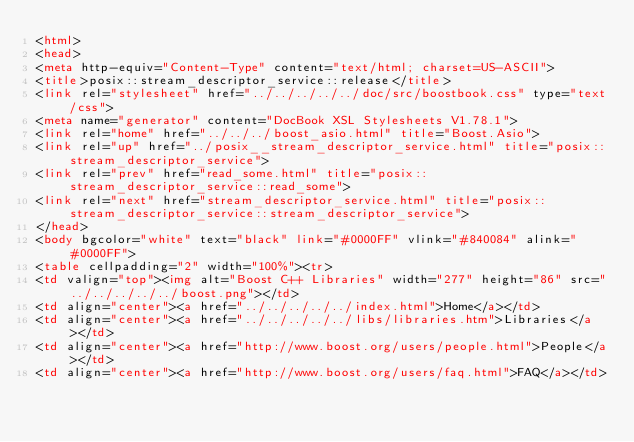<code> <loc_0><loc_0><loc_500><loc_500><_HTML_><html>
<head>
<meta http-equiv="Content-Type" content="text/html; charset=US-ASCII">
<title>posix::stream_descriptor_service::release</title>
<link rel="stylesheet" href="../../../../../doc/src/boostbook.css" type="text/css">
<meta name="generator" content="DocBook XSL Stylesheets V1.78.1">
<link rel="home" href="../../../boost_asio.html" title="Boost.Asio">
<link rel="up" href="../posix__stream_descriptor_service.html" title="posix::stream_descriptor_service">
<link rel="prev" href="read_some.html" title="posix::stream_descriptor_service::read_some">
<link rel="next" href="stream_descriptor_service.html" title="posix::stream_descriptor_service::stream_descriptor_service">
</head>
<body bgcolor="white" text="black" link="#0000FF" vlink="#840084" alink="#0000FF">
<table cellpadding="2" width="100%"><tr>
<td valign="top"><img alt="Boost C++ Libraries" width="277" height="86" src="../../../../../boost.png"></td>
<td align="center"><a href="../../../../../index.html">Home</a></td>
<td align="center"><a href="../../../../../libs/libraries.htm">Libraries</a></td>
<td align="center"><a href="http://www.boost.org/users/people.html">People</a></td>
<td align="center"><a href="http://www.boost.org/users/faq.html">FAQ</a></td></code> 